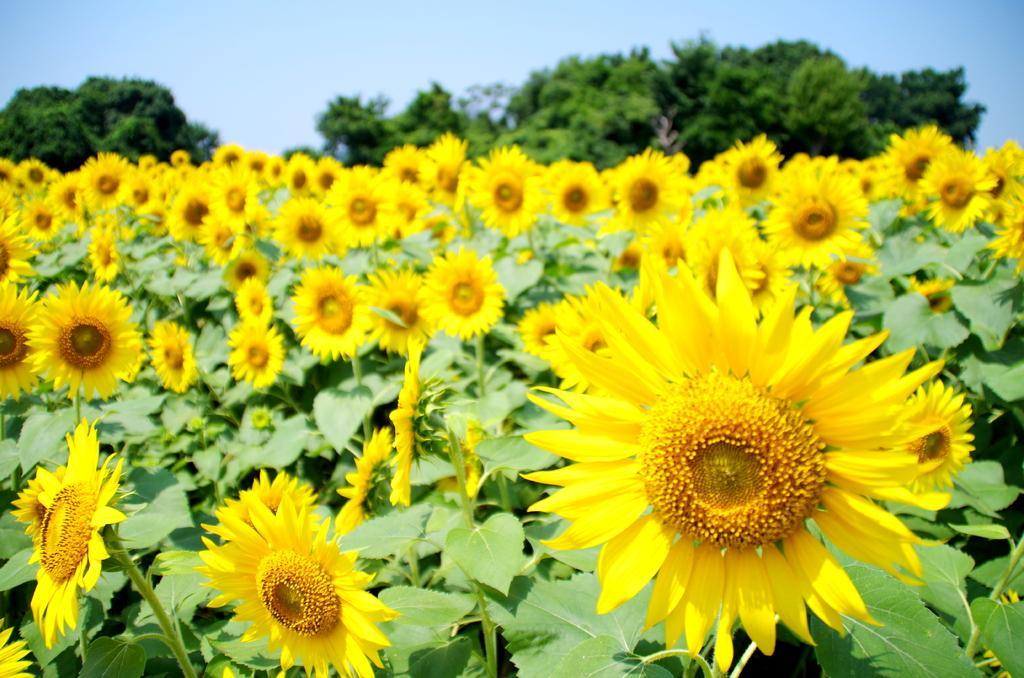Please provide a concise description of this image. In this image we can see there are plants and flowers. And at the back there are trees. At the top there is a sky. 